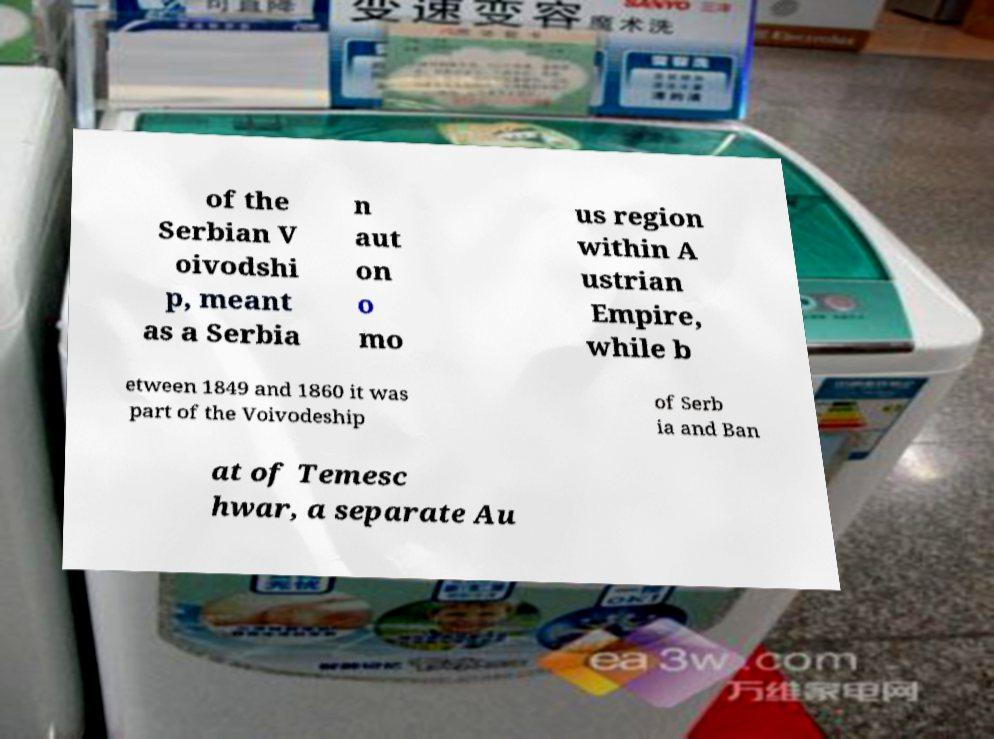I need the written content from this picture converted into text. Can you do that? of the Serbian V oivodshi p, meant as a Serbia n aut on o mo us region within A ustrian Empire, while b etween 1849 and 1860 it was part of the Voivodeship of Serb ia and Ban at of Temesc hwar, a separate Au 